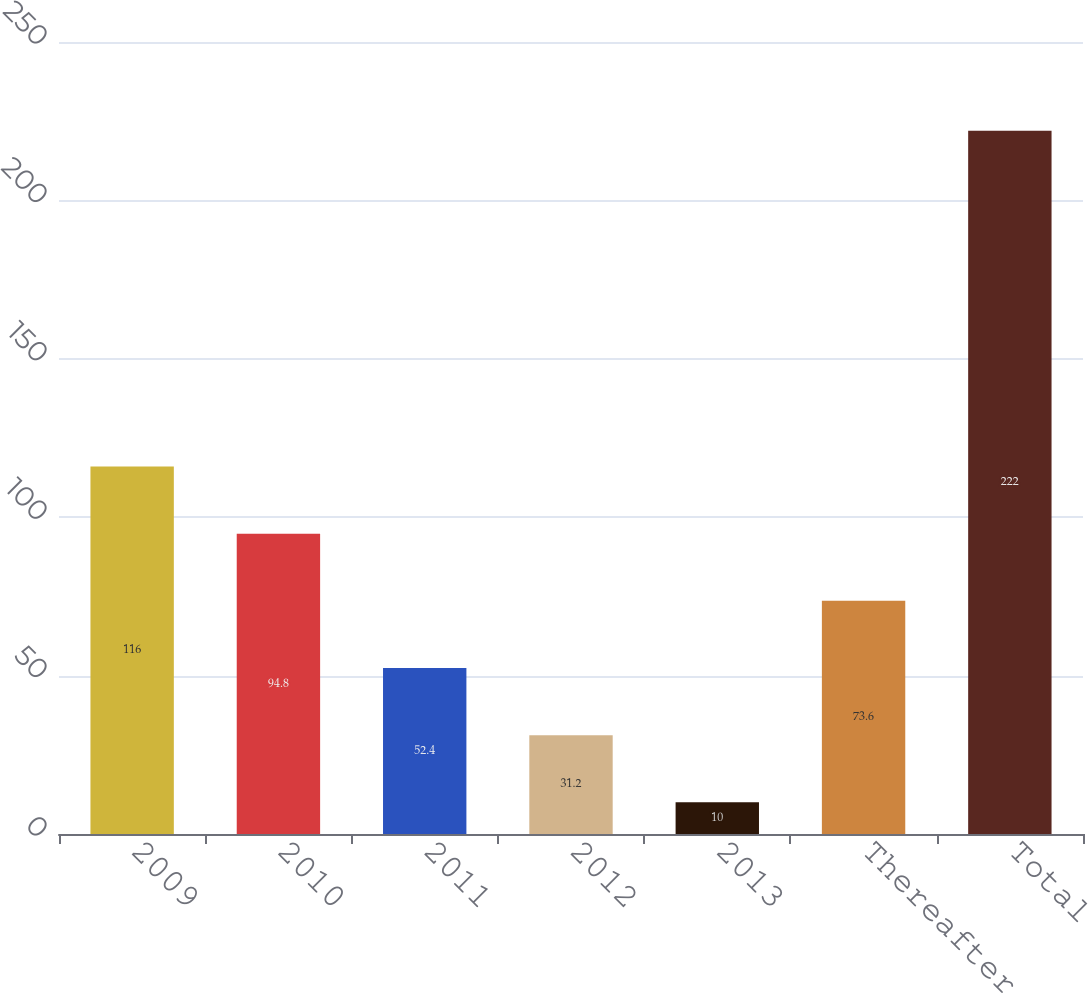Convert chart. <chart><loc_0><loc_0><loc_500><loc_500><bar_chart><fcel>2009<fcel>2010<fcel>2011<fcel>2012<fcel>2013<fcel>Thereafter<fcel>Total<nl><fcel>116<fcel>94.8<fcel>52.4<fcel>31.2<fcel>10<fcel>73.6<fcel>222<nl></chart> 